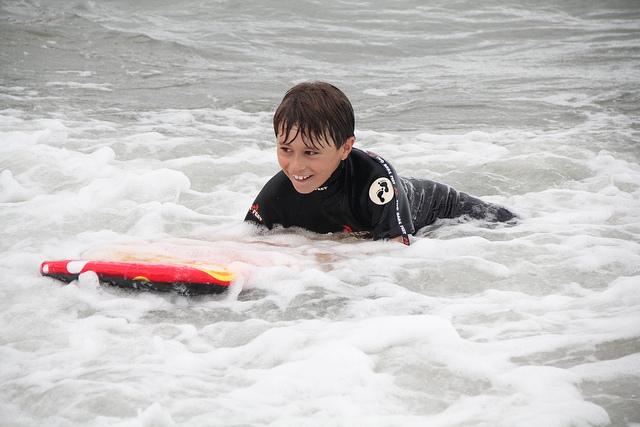How does the water look?
Quick response, please. Wet. Is this boy water skiing?
Short answer required. No. What color is he wearing?
Give a very brief answer. Black. Is the boy wearing a shirt?
Write a very short answer. Yes. Is the boy sad?
Short answer required. No. 